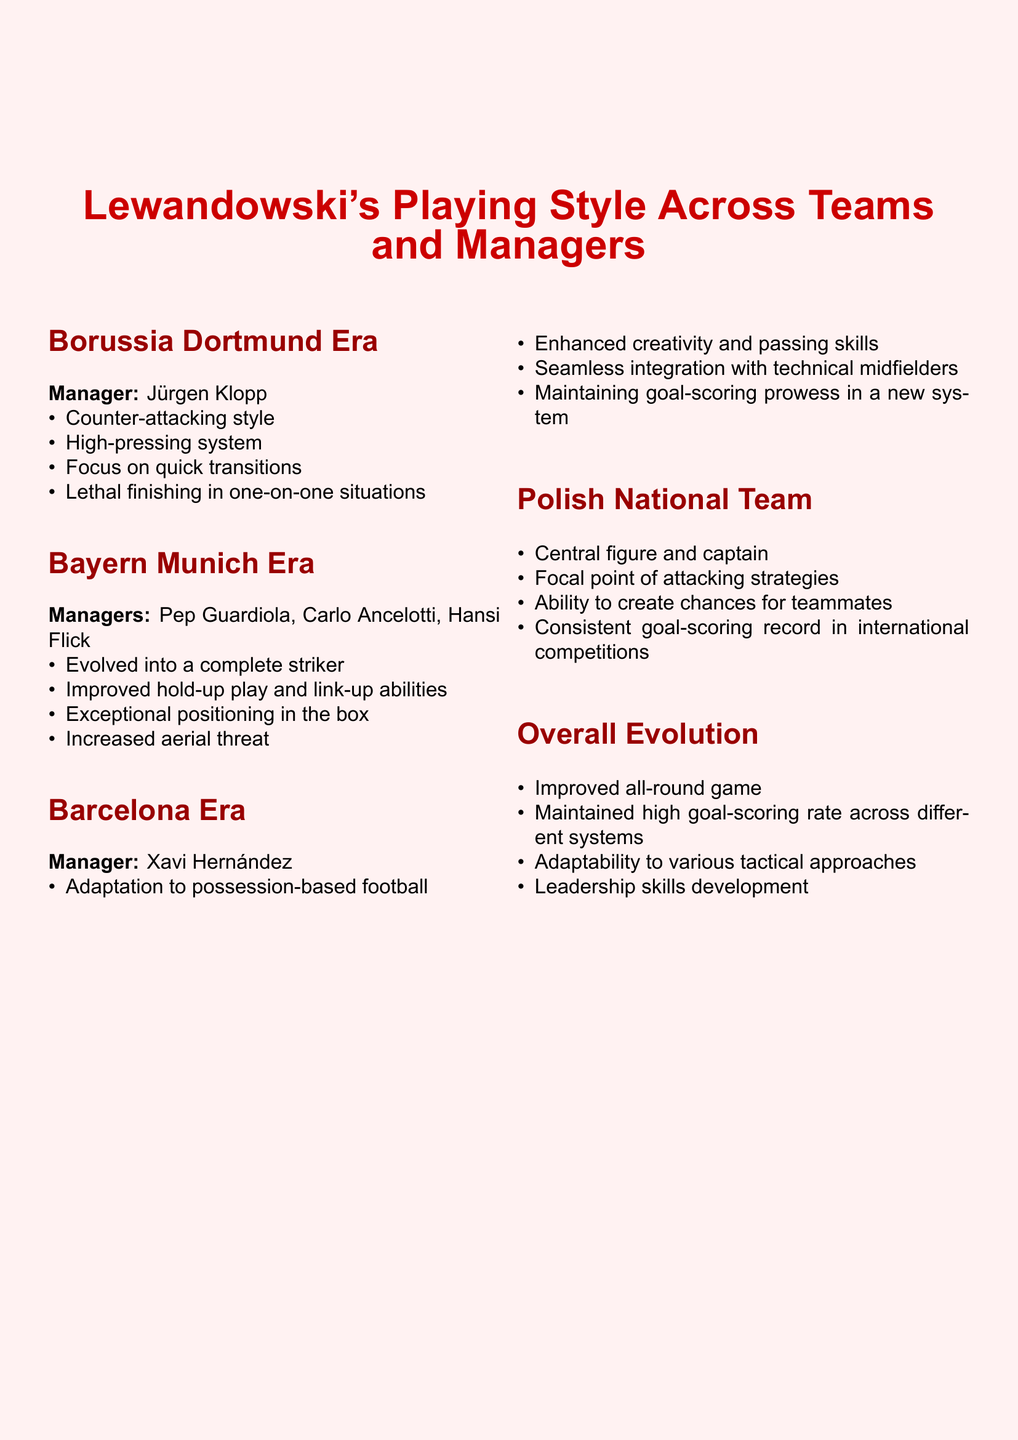What was Robert Lewandowski's playing style at Borussia Dortmund? The document states that his playing style at Borussia Dortmund included a counter-attacking style, high-pressing system, focus on quick transitions, and lethal finishing in one-on-one situations.
Answer: Counter-attacking style Who was the manager during Lewandowski's time at Borussia Dortmund? The document specifies that Jürgen Klopp was the manager during Lewandowski's Borussia Dortmund era.
Answer: Jürgen Klopp What key aspect of Lewandowski's game improved during his Bayern Munich era? The document highlights that Lewandowski evolved into a complete striker and improved his hold-up play and link-up abilities.
Answer: Complete striker Which system did Lewandowski adapt to at Barcelona? According to the document, Lewandowski adapted to possession-based football during his time at Barcelona under Xavi Hernández.
Answer: Possession-based football What role does Lewandowski play in the Polish National Team? The document describes him as the central figure and captain of the Polish National Team.
Answer: Central figure and captain How does the document characterize Lewandowski's overall evolution? The document states that his overall evolution includes an improved all-round game and maintained high goal-scoring rate across different systems.
Answer: Improved all-round game What was one of Lewandowski's traits in the Bayern Munich era? The document mentions exceptional positioning in the box as one of Lewandowski's traits during his Bayern Munich era.
Answer: Exceptional positioning Which important skill did Lewandowski enhance while at Barcelona? The document highlights enhanced creativity and passing skills as an important improvement for Lewandowski during his Barcelona era.
Answer: Creativity and passing skills 